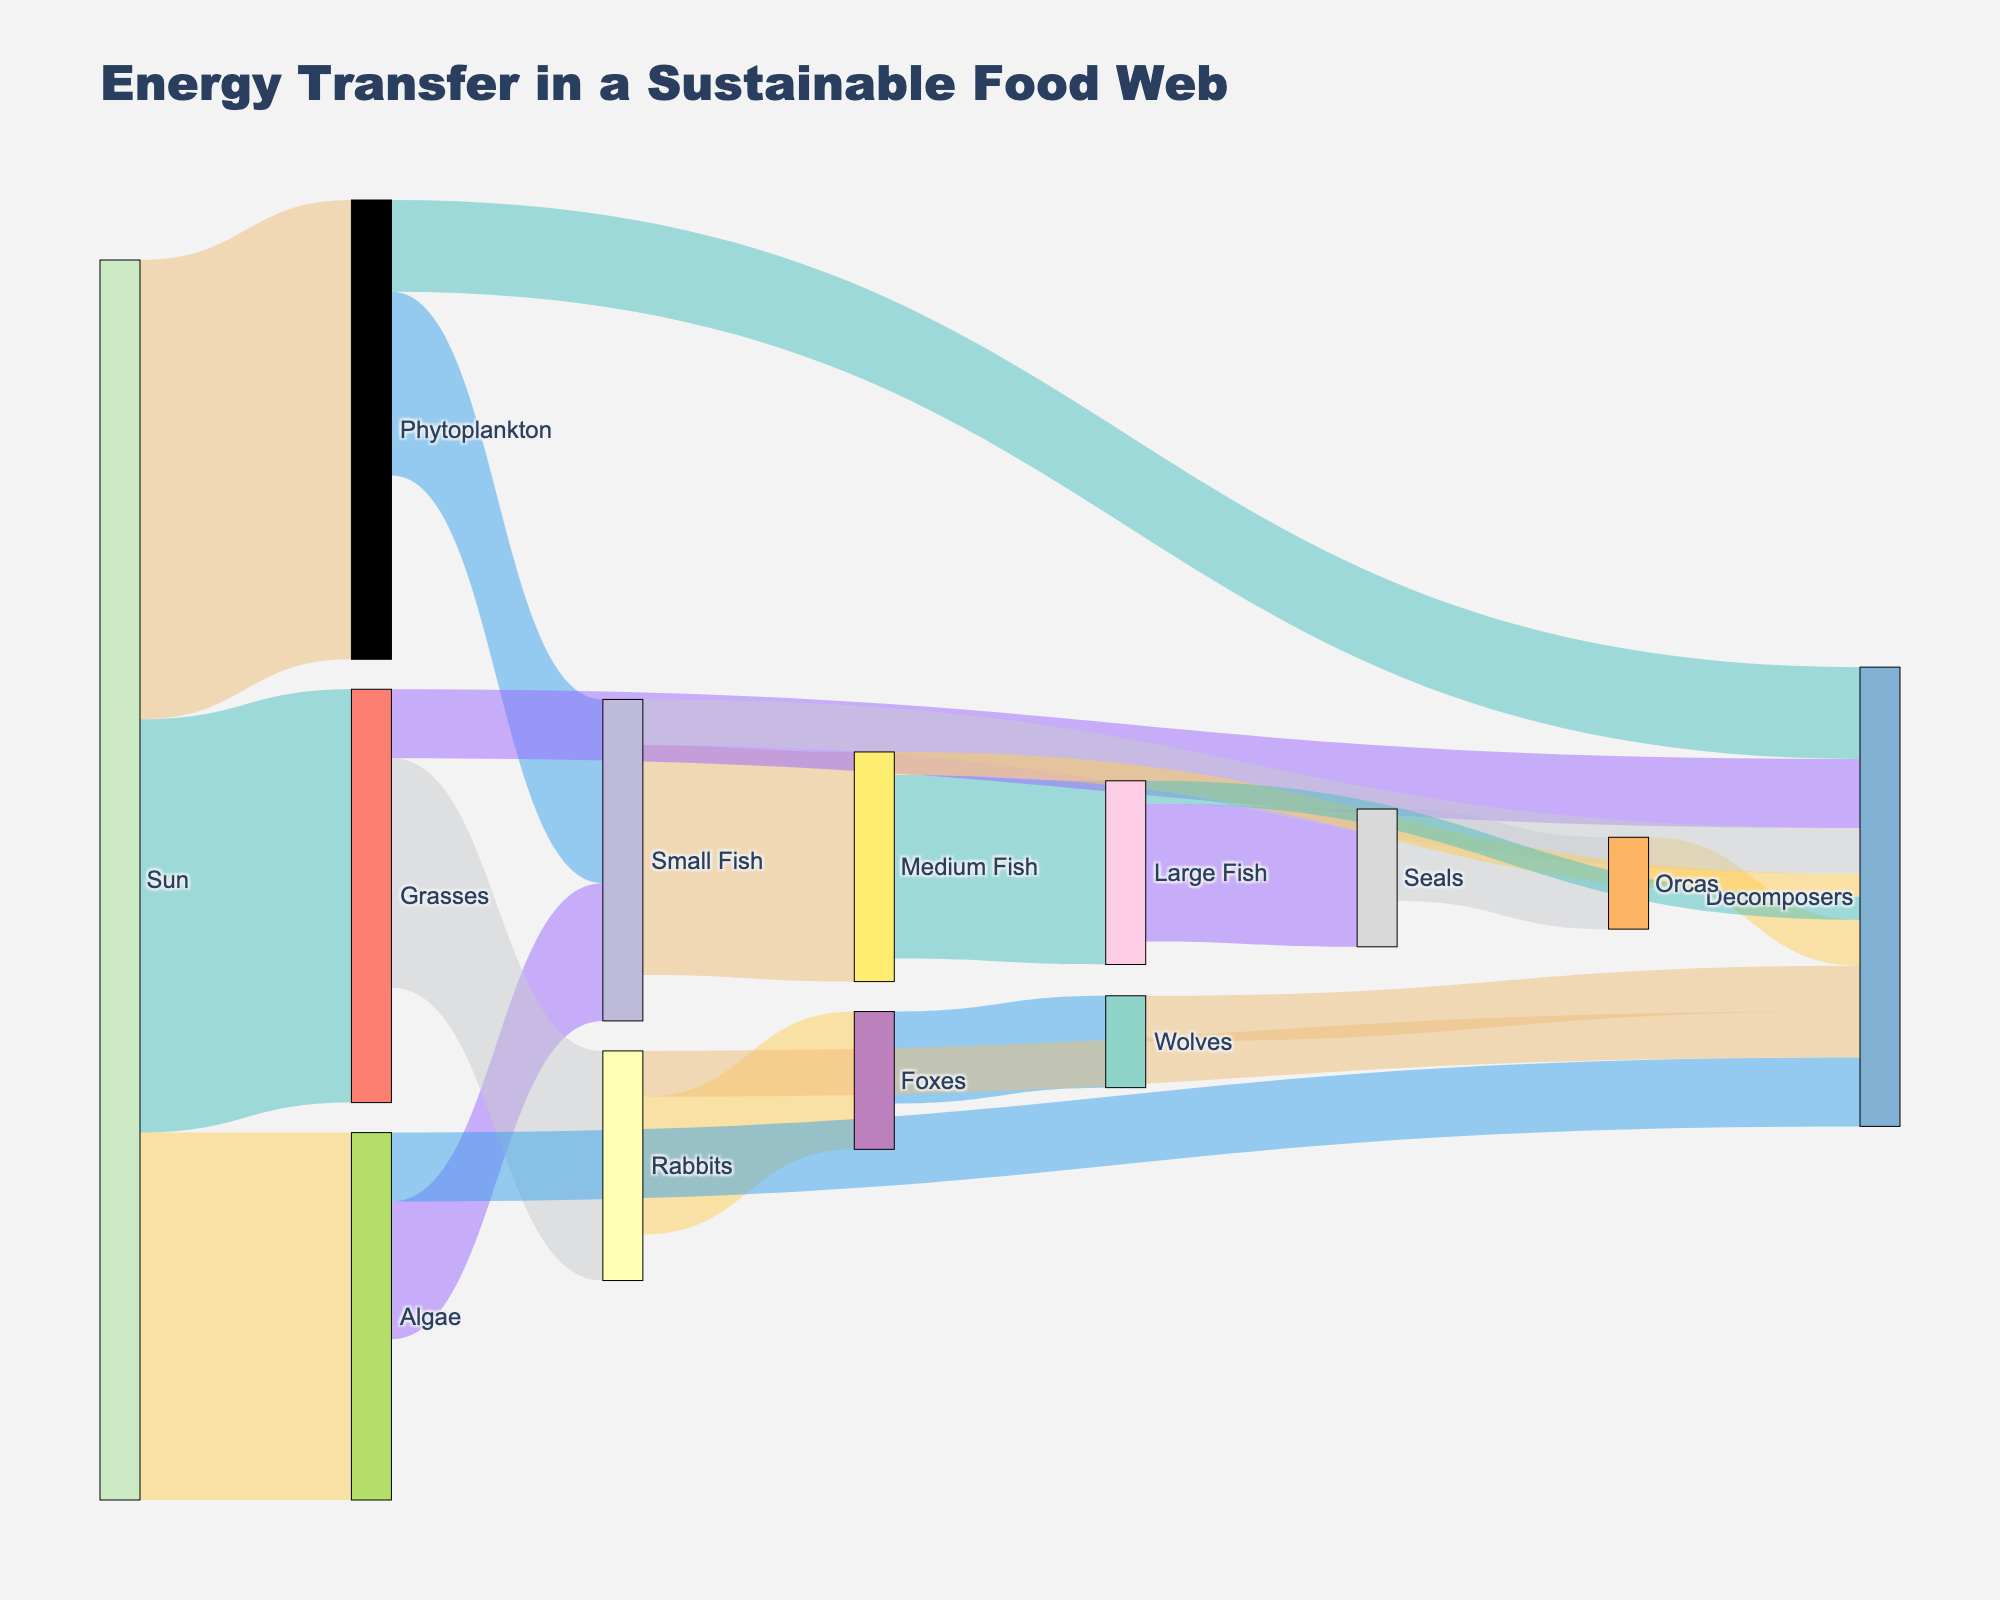What is the title of the diagram? The title is located at the top of the diagram and reads "Energy Transfer in a Sustainable Food Web"
Answer: Energy Transfer in a Sustainable Food Web How many major sources does the Sun transfer energy to directly? The Sun directly transfers energy to three sources: Phytoplankton, Algae, and Grasses as seen by the arrows originating from the Sun and leading directly to these three targets
Answer: 3 Which organism receives the highest amount of energy directly from its source? By observing the values connected by the arrows, Phytoplankton receives 100 units of energy directly from the Sun
Answer: Phytoplankton How much energy does the Fox transfer to Wolves? Follow the arrow from Foxes to Wolves; it shows a value of 20 units of energy
Answer: 20 How much total energy is transferred to decomposers from all sources? Identify all arrows pointing to Decomposers and sum their values: 20 (Phytoplankton) + 15 (Algae) + 15 (Grasses) + 10 (Small Fish) + 10 (Rabbits) + 5 (Medium Fish) + 5 (Large Fish) + 10 (Wolves) + 10 (Orcas) = 100 units
Answer: 100 Which organism acts as an intermediary transferring energy from small fish to large fish? Trace the path from Small Fish: Small Fish transfers energy to Medium Fish, and Medium Fish then transfers this to Large Fish
Answer: Medium Fish Who receives more energy from their immediate food source: Seals or Wolves? Compare the values transferred to each: Seals receive 30 units from Large Fish, while Wolves receive 20 units from Foxes. 30 is greater than 20
Answer: Seals What is the combined energy transferred from Sun to all primary producers? Sum the values of energy transferred from the Sun to Phytoplankton, Algae, and Grasses: 100 + 80 + 90 = 270 units
Answer: 270 In terms of energy transferred to decomposers, which primary producer contributes the least? Compare the values showing decomposition paths from Phytoplankton (20), Algae (15), and Grasses (15); the smallest value is 15 units from both Algae and Grasses. Neither contributes less than the other
Answer: Algae and Grasses 